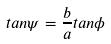<formula> <loc_0><loc_0><loc_500><loc_500>t a n \psi = \frac { b } { a } t a n \phi</formula> 